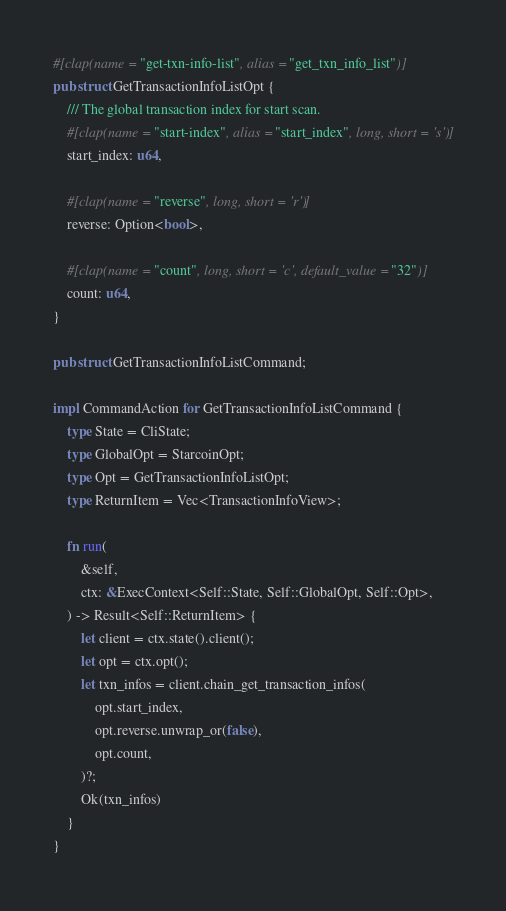Convert code to text. <code><loc_0><loc_0><loc_500><loc_500><_Rust_>#[clap(name = "get-txn-info-list", alias = "get_txn_info_list")]
pub struct GetTransactionInfoListOpt {
    /// The global transaction index for start scan.
    #[clap(name = "start-index", alias = "start_index", long, short = 's')]
    start_index: u64,

    #[clap(name = "reverse", long, short = 'r')]
    reverse: Option<bool>,

    #[clap(name = "count", long, short = 'c', default_value = "32")]
    count: u64,
}

pub struct GetTransactionInfoListCommand;

impl CommandAction for GetTransactionInfoListCommand {
    type State = CliState;
    type GlobalOpt = StarcoinOpt;
    type Opt = GetTransactionInfoListOpt;
    type ReturnItem = Vec<TransactionInfoView>;

    fn run(
        &self,
        ctx: &ExecContext<Self::State, Self::GlobalOpt, Self::Opt>,
    ) -> Result<Self::ReturnItem> {
        let client = ctx.state().client();
        let opt = ctx.opt();
        let txn_infos = client.chain_get_transaction_infos(
            opt.start_index,
            opt.reverse.unwrap_or(false),
            opt.count,
        )?;
        Ok(txn_infos)
    }
}
</code> 